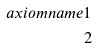Convert formula to latex. <formula><loc_0><loc_0><loc_500><loc_500>\ a x i o m n a m e { 1 } \\ 2</formula> 